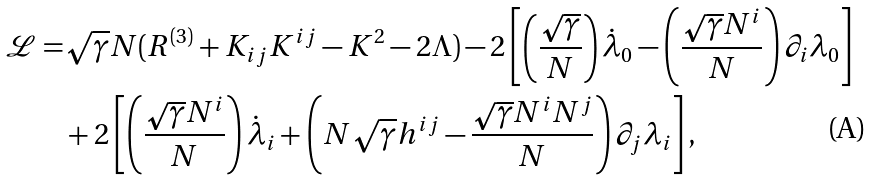<formula> <loc_0><loc_0><loc_500><loc_500>\mathcal { L } = & \sqrt { \gamma } N ( R ^ { ( 3 ) } + K _ { i j } K ^ { i j } - K ^ { 2 } - 2 \Lambda ) - 2 \left [ \left ( \frac { \sqrt { \gamma } } { N } \right ) \dot { \lambda } _ { 0 } - \left ( \frac { \sqrt { \gamma } N ^ { i } } { N } \right ) \partial _ { i } \lambda _ { 0 } \right ] \\ & + 2 \left [ \left ( \frac { \sqrt { \gamma } N ^ { i } } { N } \right ) \dot { \lambda } _ { i } + \left ( N \sqrt { \gamma } h ^ { i j } - \frac { \sqrt { \gamma } N ^ { i } N ^ { j } } { N } \right ) \partial _ { j } \lambda _ { i } \right ] ,</formula> 